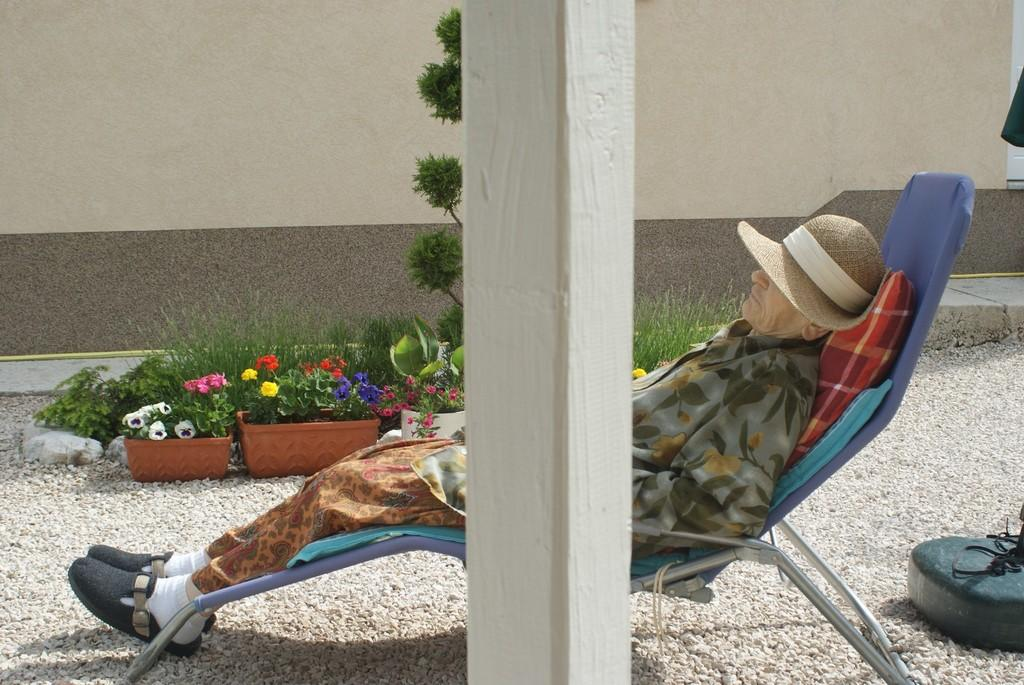Who is the main subject in the image? There is an old man in the image. What is the old man doing in the image? The old man is sleeping in a rocking chair. What can be seen in the center of the image? There is a pillar in the center of the image. What type of vegetation is visible in the background of the image? There are plants in the background of the image. What type of horn can be seen on the old man's head in the image? There is no horn present on the old man's head in the image. What arithmetic problem is the old man solving in the image? The old man is sleeping in the image, so he is not solving any arithmetic problems. 